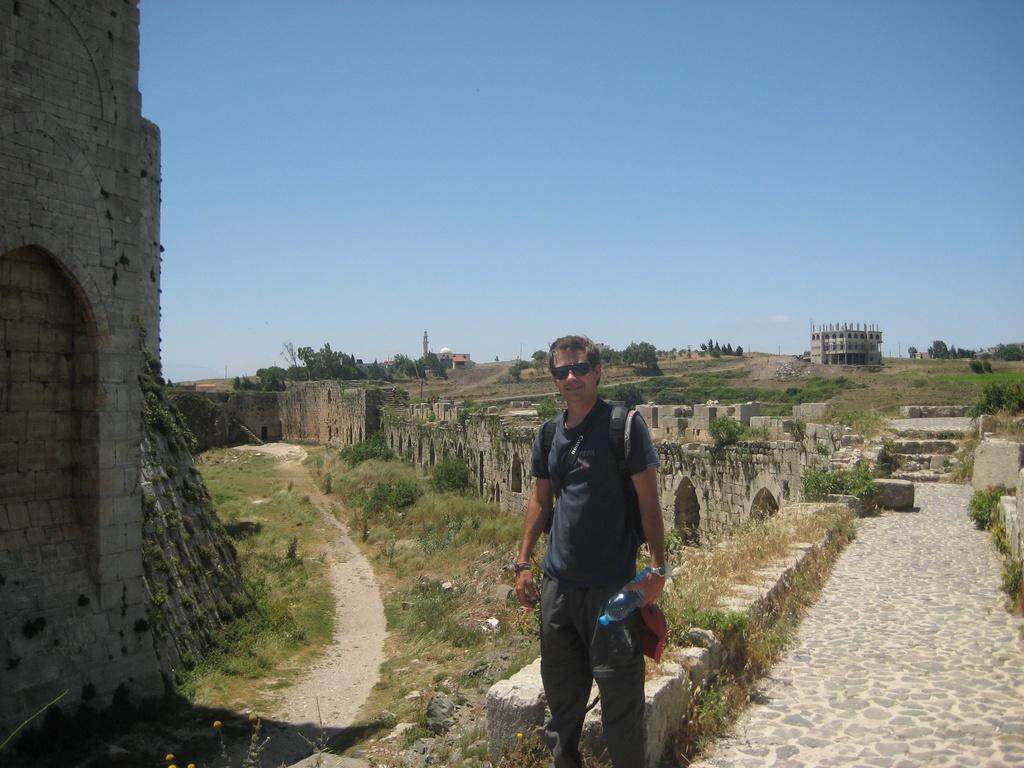What is the person in the image wearing? The person is wearing a dress in the image. What is the person holding in the image? The person is holding a bottle in the image. What type of structures can be seen in the image? There are forts in the image. What type of vegetation is present in the image? There are plants in the image. What can be seen in the background of the image? There is a building, many trees, and the sky visible in the background of the image. What type of cookware is the person using to cook in the image? There is no cookware or cooking activity present in the image. 